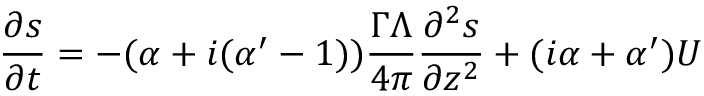<formula> <loc_0><loc_0><loc_500><loc_500>\frac { \partial s } { \partial t } = - ( \alpha + i ( \alpha ^ { \prime } - 1 ) ) \frac { \Gamma \Lambda } { 4 \pi } \frac { \partial ^ { 2 } s } { \partial z ^ { 2 } } + ( i \alpha + \alpha ^ { \prime } ) U</formula> 